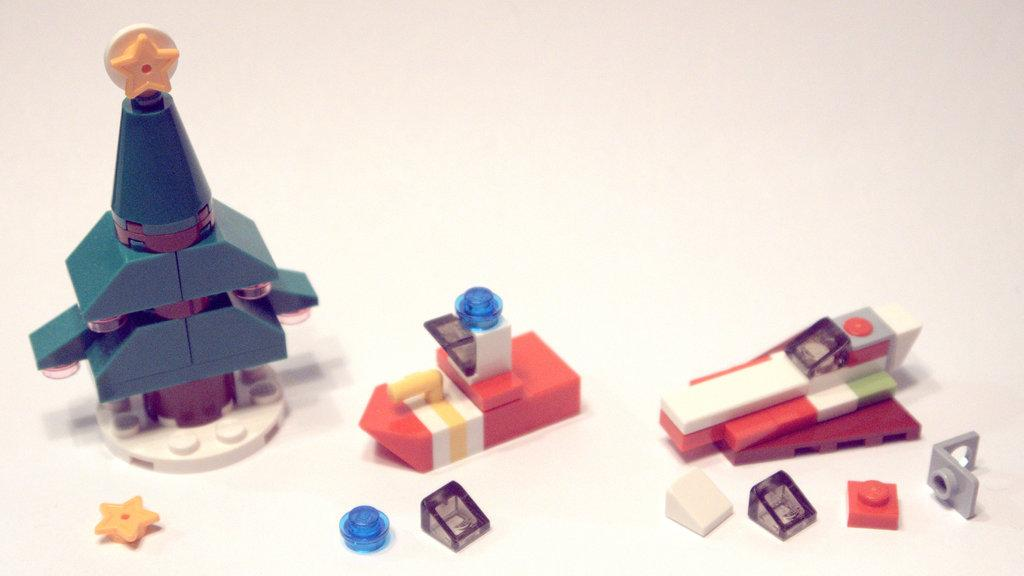What is on the floor in the image? There are objects on the floor in the image. What type of hope can be seen in the image? There is no hope present in the image; it features objects on the floor. What reward is being given to the maid in the image? There is no maid or reward present in the image. 